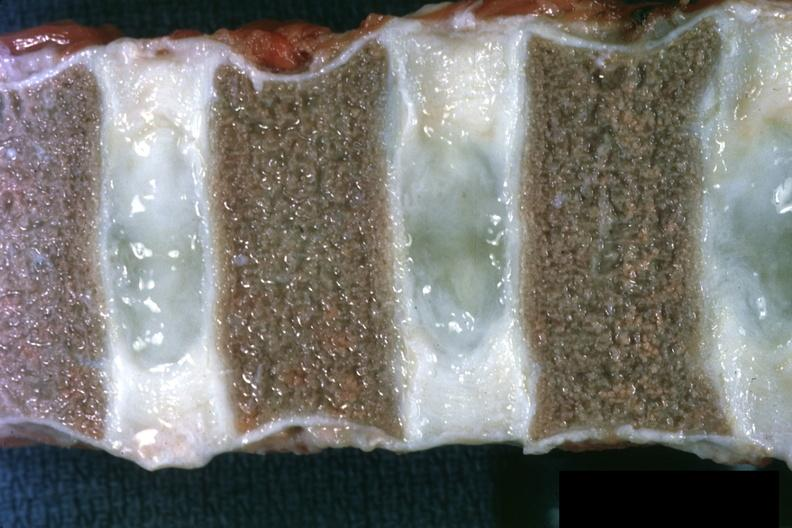what are well shown?
Answer the question using a single word or phrase. Not too spectacular discs 